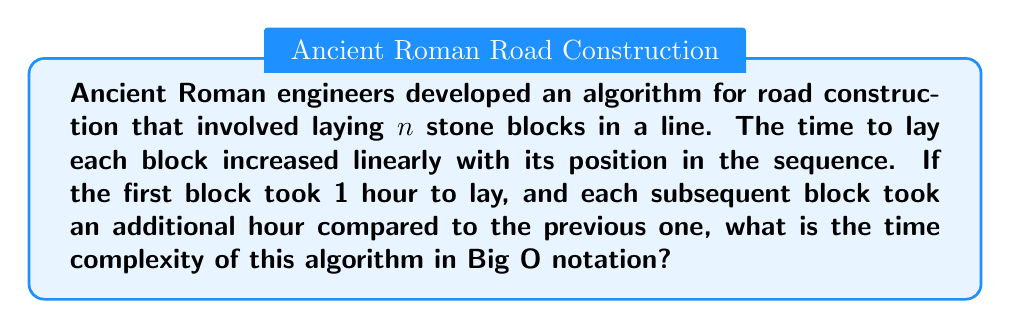Help me with this question. Let's analyze this problem step-by-step:

1) First, let's identify the time taken for each block:
   - Block 1: 1 hour
   - Block 2: 2 hours
   - Block 3: 3 hours
   ...
   - Block n: n hours

2) The total time $T(n)$ for laying $n$ blocks is the sum of these times:

   $$T(n) = 1 + 2 + 3 + ... + n$$

3) This is a well-known series in mathematics, called the arithmetic series or triangular numbers. The sum of this series is given by the formula:

   $$T(n) = \frac{n(n+1)}{2}$$

4) Expanding this:

   $$T(n) = \frac{n^2 + n}{2}$$

5) In Big O notation, we're concerned with the growth rate as $n$ becomes large. The $n^2$ term will dominate for large $n$, so we can ignore the lower-order terms:

   $$T(n) \approx \frac{n^2}{2}$$

6) Constants (like $\frac{1}{2}$) are also ignored in Big O notation.

Therefore, the time complexity of this algorithm is $O(n^2)$.

This quadratic time complexity reflects the increasing difficulty of laying each subsequent block in the Roman road construction algorithm.
Answer: $O(n^2)$ 